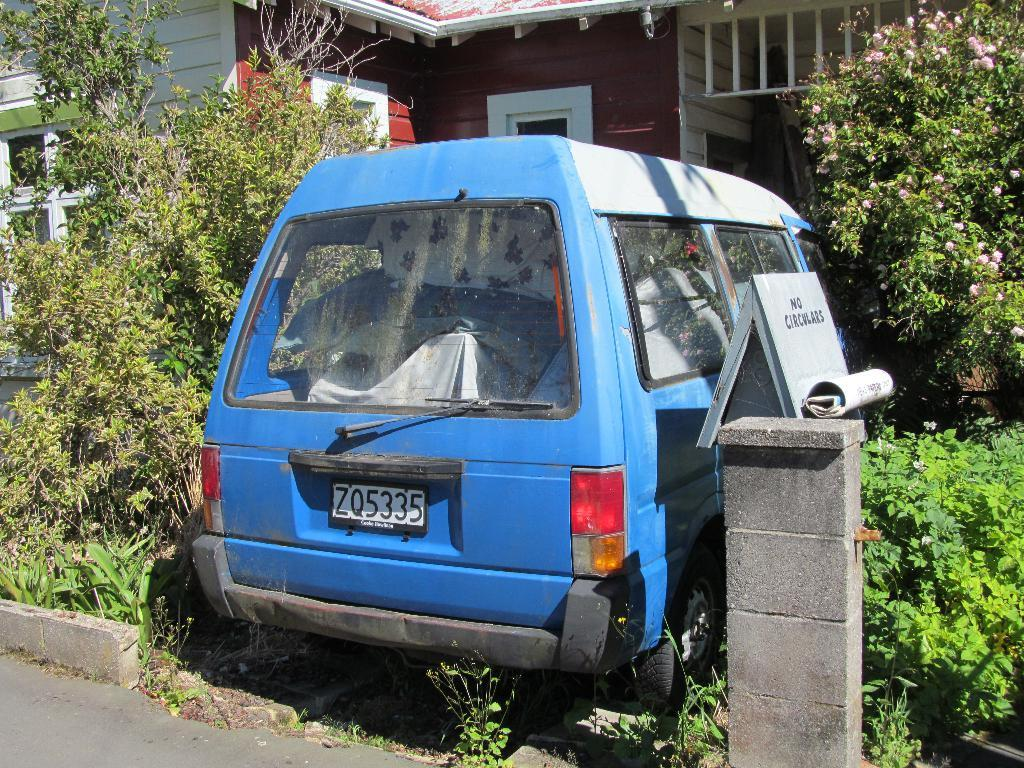<image>
Render a clear and concise summary of the photo. A blue van with a license plate that has ZQ5335 on it. 